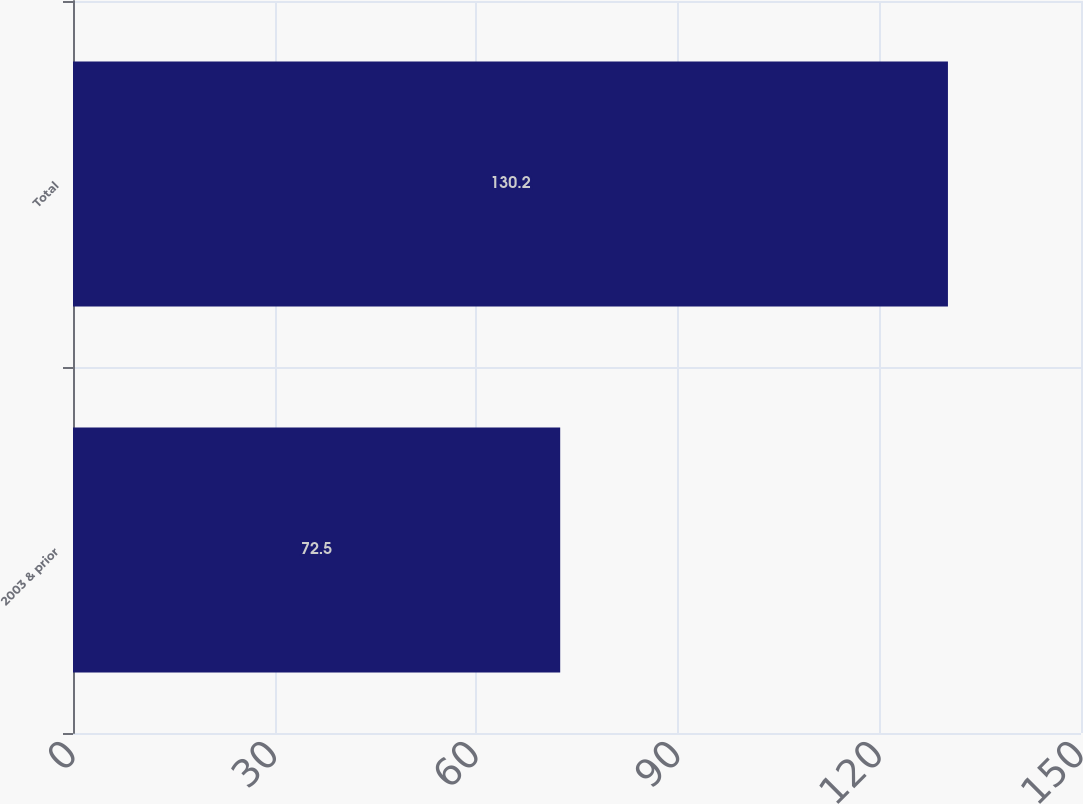Convert chart. <chart><loc_0><loc_0><loc_500><loc_500><bar_chart><fcel>2003 & prior<fcel>Total<nl><fcel>72.5<fcel>130.2<nl></chart> 